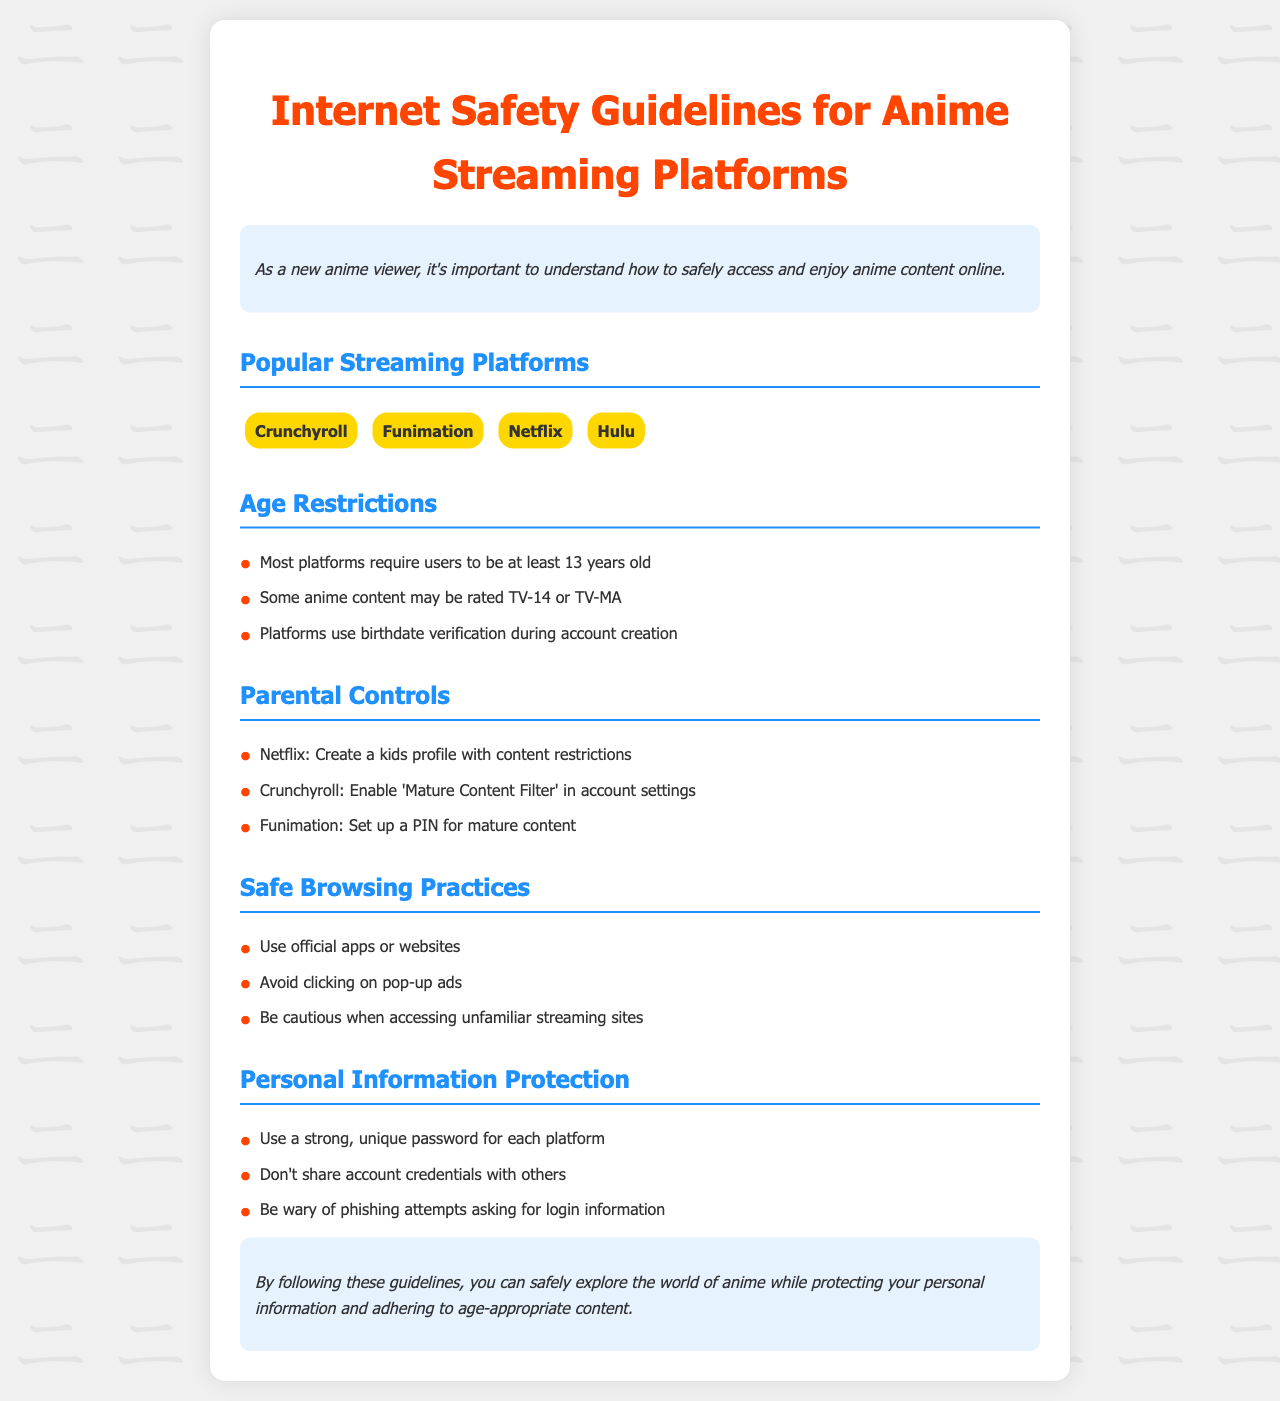What are the names of popular streaming platforms mentioned? The document lists specific streaming platforms for anime viewing, which are Crunchyroll, Funimation, Netflix, and Hulu.
Answer: Crunchyroll, Funimation, Netflix, Hulu What is the minimum age requirement for most platforms? The document specifies that most platforms require users to be at least 13 years old.
Answer: 13 years old What content filters can be enabled on Crunchyroll? The document states that Crunchyroll allows users to enable the 'Mature Content Filter' in account settings for content management.
Answer: Mature Content Filter Which platform allows the creation of kids profiles? The document mentions that Netflix provides the option to create a kids profile with content restrictions.
Answer: Netflix What should users avoid when browsing? The document suggests being cautious and avoiding clicking on pop-up ads for safe browsing practices.
Answer: Clicking on pop-up ads Why is it important to have a strong, unique password? The document suggests that using a strong, unique password for each platform protects personal information.
Answer: Protects personal information What is a common age rating for some anime content? The document mentions that some anime content may be rated TV-14 or TV-MA.
Answer: TV-14 or TV-MA What must users verify when creating an account? The document states that platforms require birthdate verification during account creation.
Answer: Birthdate verification 